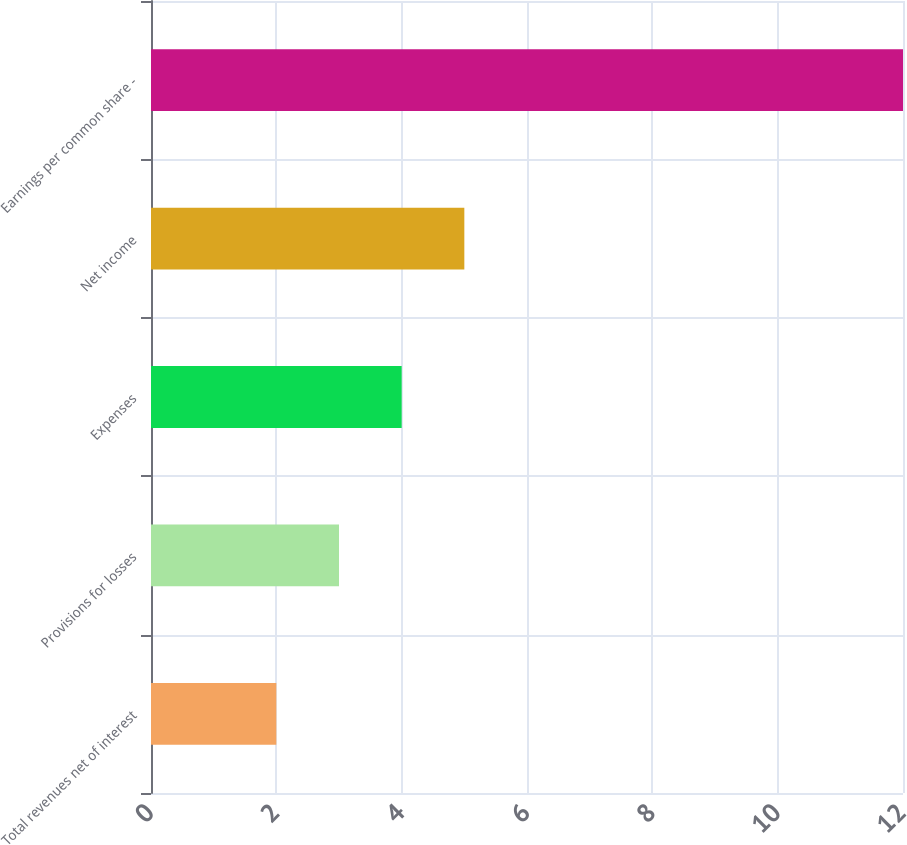Convert chart to OTSL. <chart><loc_0><loc_0><loc_500><loc_500><bar_chart><fcel>Total revenues net of interest<fcel>Provisions for losses<fcel>Expenses<fcel>Net income<fcel>Earnings per common share -<nl><fcel>2<fcel>3<fcel>4<fcel>5<fcel>12<nl></chart> 